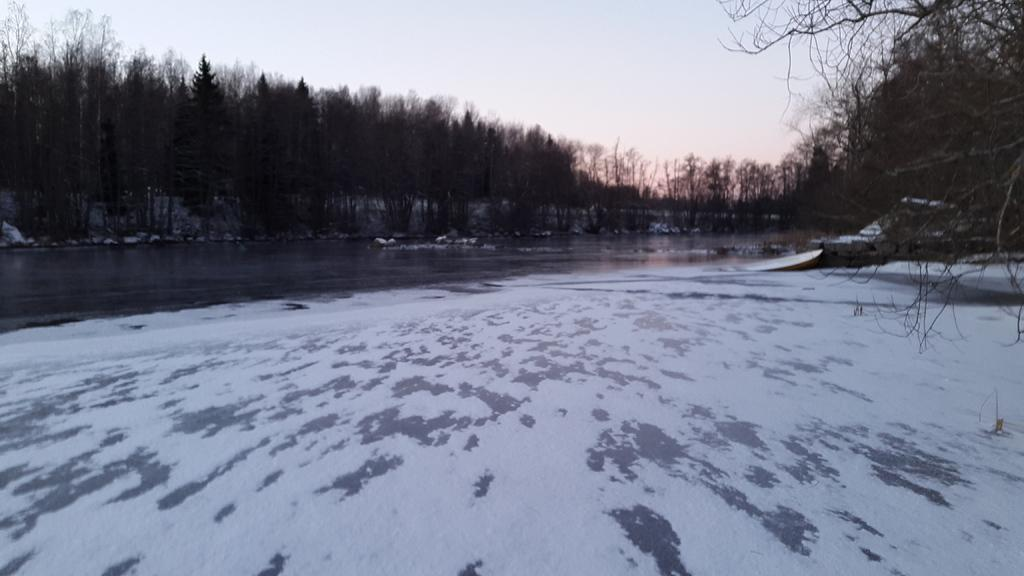What is present in the foreground of the image? There is water and snow in the foreground of the image. What can be seen in the background of the image? There are trees and the sky visible in the background of the image. What type of pie is being served on a rock in the image? There is no pie or rock present in the image; it features water, snow, trees, and the sky. What color is the neck of the person in the image? There is no person present in the image, so it is not possible to determine the color of their neck. 